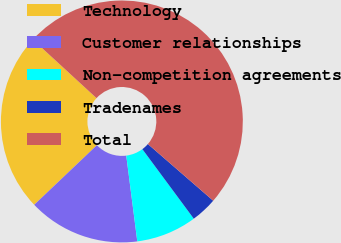<chart> <loc_0><loc_0><loc_500><loc_500><pie_chart><fcel>Technology<fcel>Customer relationships<fcel>Non-competition agreements<fcel>Tradenames<fcel>Total<nl><fcel>23.93%<fcel>14.94%<fcel>8.1%<fcel>3.49%<fcel>49.55%<nl></chart> 